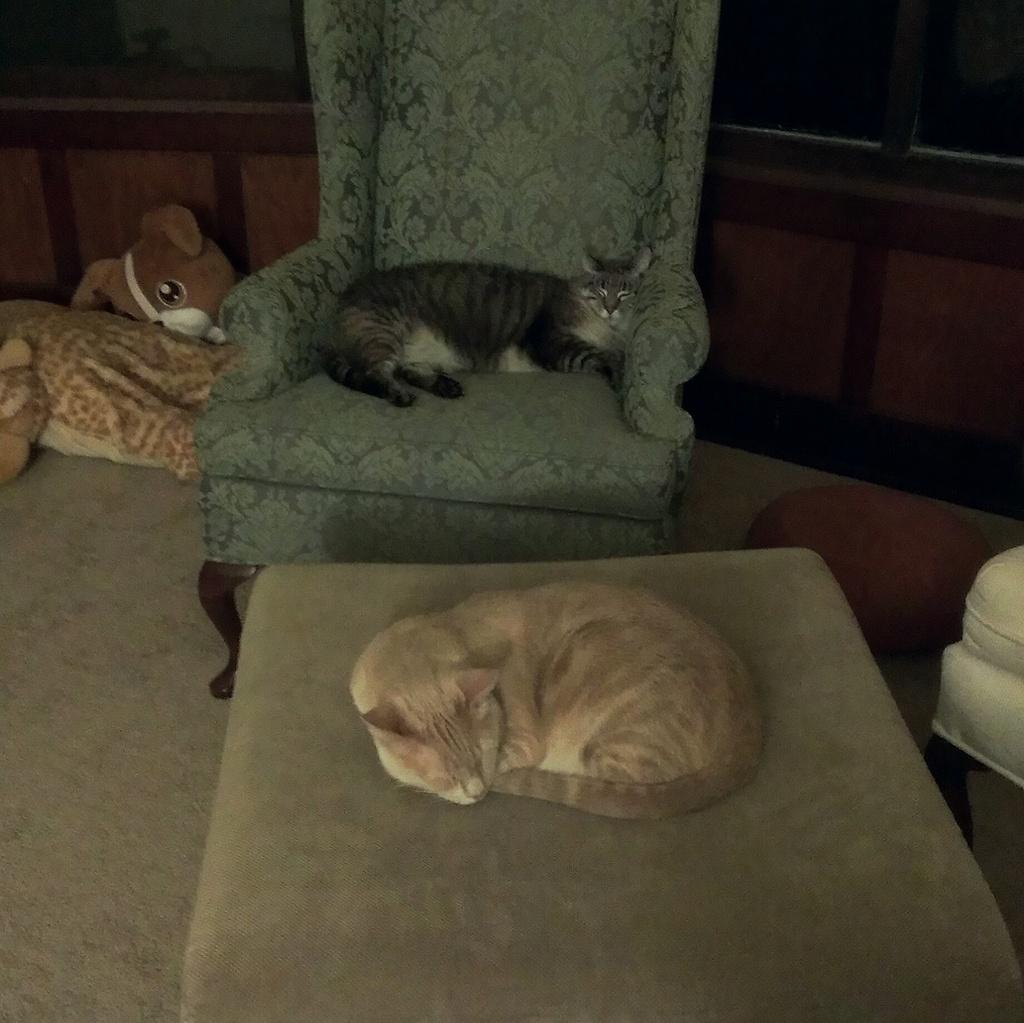How many cats are in the image? There are two cats in the image. What can be seen on the ground in the image? There are objects on the ground, including toys and chairs. What can be seen in the background of the image? The background of the image is visible. Is there a masked competitor participating in a destruction event in the image? No, there is no masked competitor or destruction event present in the image. The image features two cats and objects on the ground, with a visible background. 